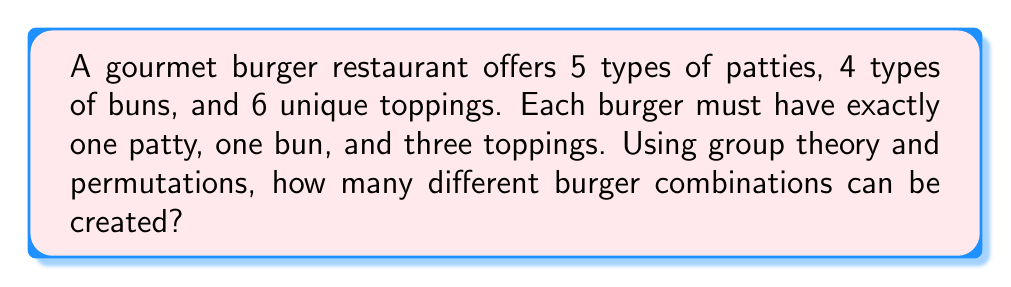Can you solve this math problem? Let's approach this step-by-step using group theory and permutation concepts:

1. First, we need to calculate the number of ways to choose the patty and bun:
   - There are 5 choices for the patty and 4 choices for the bun.
   - This gives us $5 \times 4 = 20$ combinations for patty and bun.

2. Now, we need to calculate the number of ways to choose 3 toppings from 6 options:
   - This is a combination problem, denoted as $\binom{6}{3}$ or $C(6,3)$.
   - The formula for this combination is:
     $$\binom{6}{3} = \frac{6!}{3!(6-3)!} = \frac{6!}{3!3!}$$

3. Let's calculate this combination:
   $$\frac{6 \times 5 \times 4 \times 3!}{3 \times 2 \times 1 \times 3!} = \frac{120}{6} = 20$$

4. Now, we use the multiplication principle from group theory:
   - The total number of burger combinations is the product of the number of patty-bun combinations and the number of topping combinations.
   - Total combinations = (Patty-bun combinations) $\times$ (Topping combinations)
   - Total combinations = $20 \times 20 = 400$

Therefore, the restaurant can create 400 different burger combinations.
Answer: 400 combinations 